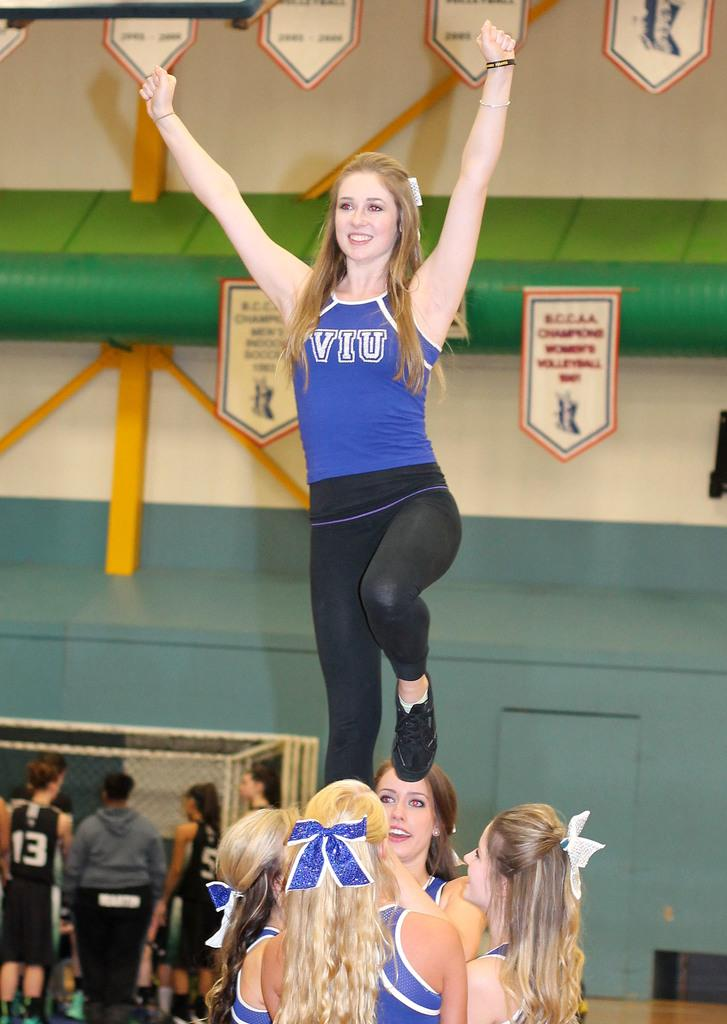<image>
Render a clear and concise summary of the photo. a cheerleader on top of girls with VIU on her shirt 